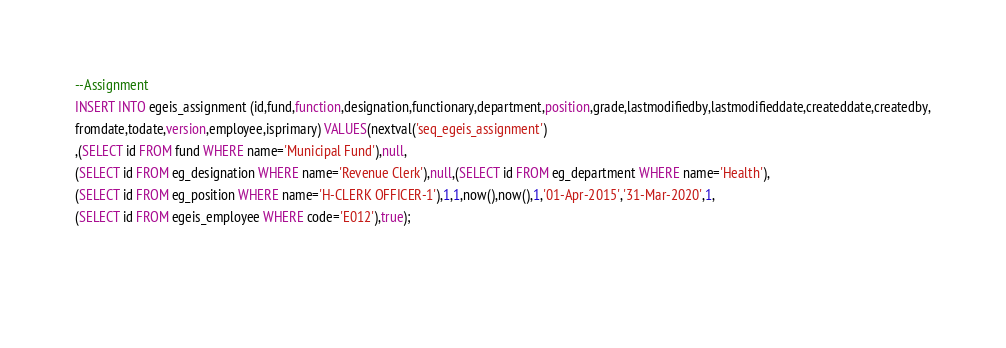Convert code to text. <code><loc_0><loc_0><loc_500><loc_500><_SQL_>
--Assignment
INSERT INTO egeis_assignment (id,fund,function,designation,functionary,department,position,grade,lastmodifiedby,lastmodifieddate,createddate,createdby,
fromdate,todate,version,employee,isprimary) VALUES(nextval('seq_egeis_assignment')
,(SELECT id FROM fund WHERE name='Municipal Fund'),null,
(SELECT id FROM eg_designation WHERE name='Revenue Clerk'),null,(SELECT id FROM eg_department WHERE name='Health'),
(SELECT id FROM eg_position WHERE name='H-CLERK OFFICER-1'),1,1,now(),now(),1,'01-Apr-2015','31-Mar-2020',1,
(SELECT id FROM egeis_employee WHERE code='E012'),true);

 </code> 